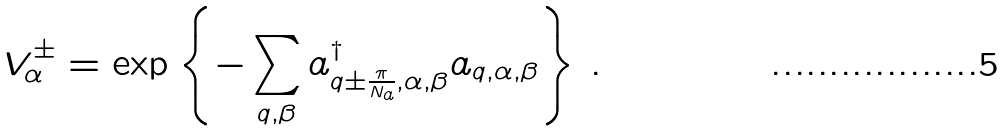<formula> <loc_0><loc_0><loc_500><loc_500>V ^ { \pm } _ { \alpha } = \exp \left \{ - \sum _ { q , \beta } a ^ { \dag } _ { q \pm \frac { \pi } { N _ { a } } , \alpha , \beta } a _ { q , \alpha , \beta } \right \} \, .</formula> 